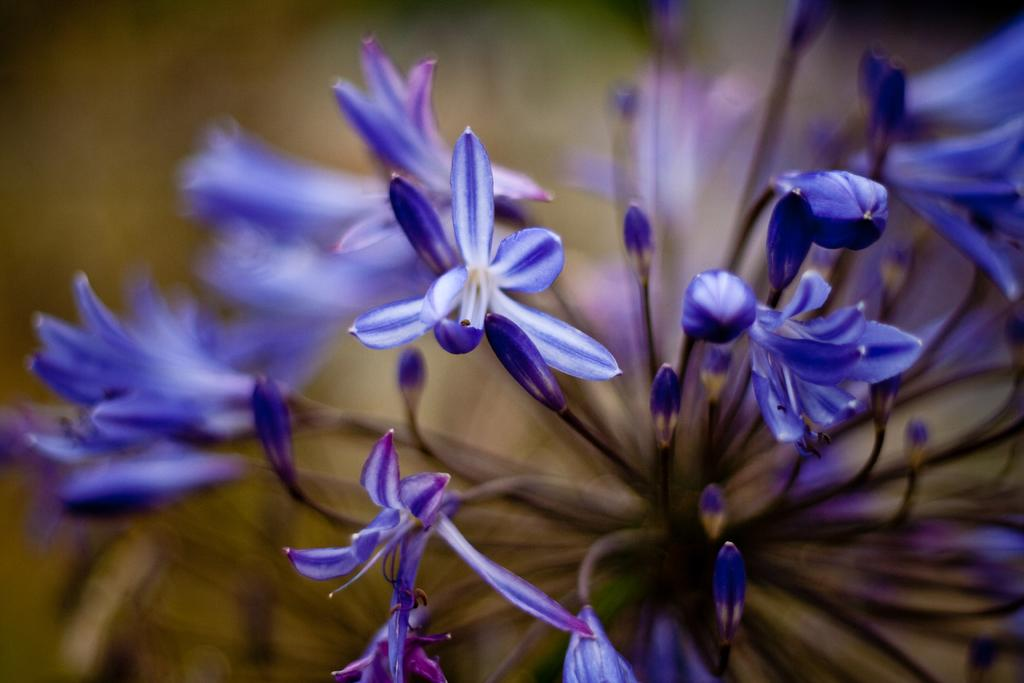What type of living organisms can be seen in the image? Flowers are visible in the image. What type of baby can be seen playing with the grass in the image? There is no baby or grass present in the image; it only features flowers. 